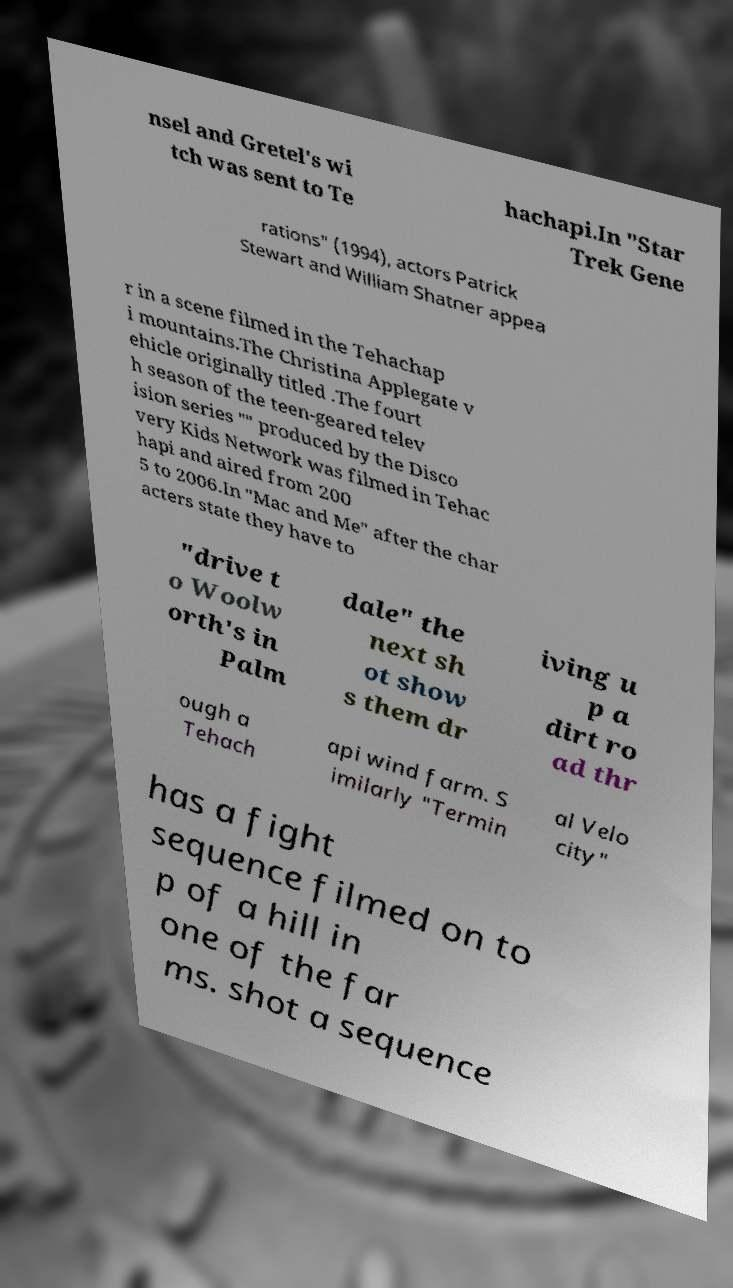I need the written content from this picture converted into text. Can you do that? nsel and Gretel's wi tch was sent to Te hachapi.In "Star Trek Gene rations" (1994), actors Patrick Stewart and William Shatner appea r in a scene filmed in the Tehachap i mountains.The Christina Applegate v ehicle originally titled .The fourt h season of the teen-geared telev ision series "" produced by the Disco very Kids Network was filmed in Tehac hapi and aired from 200 5 to 2006.In "Mac and Me" after the char acters state they have to "drive t o Woolw orth's in Palm dale" the next sh ot show s them dr iving u p a dirt ro ad thr ough a Tehach api wind farm. S imilarly "Termin al Velo city" has a fight sequence filmed on to p of a hill in one of the far ms. shot a sequence 